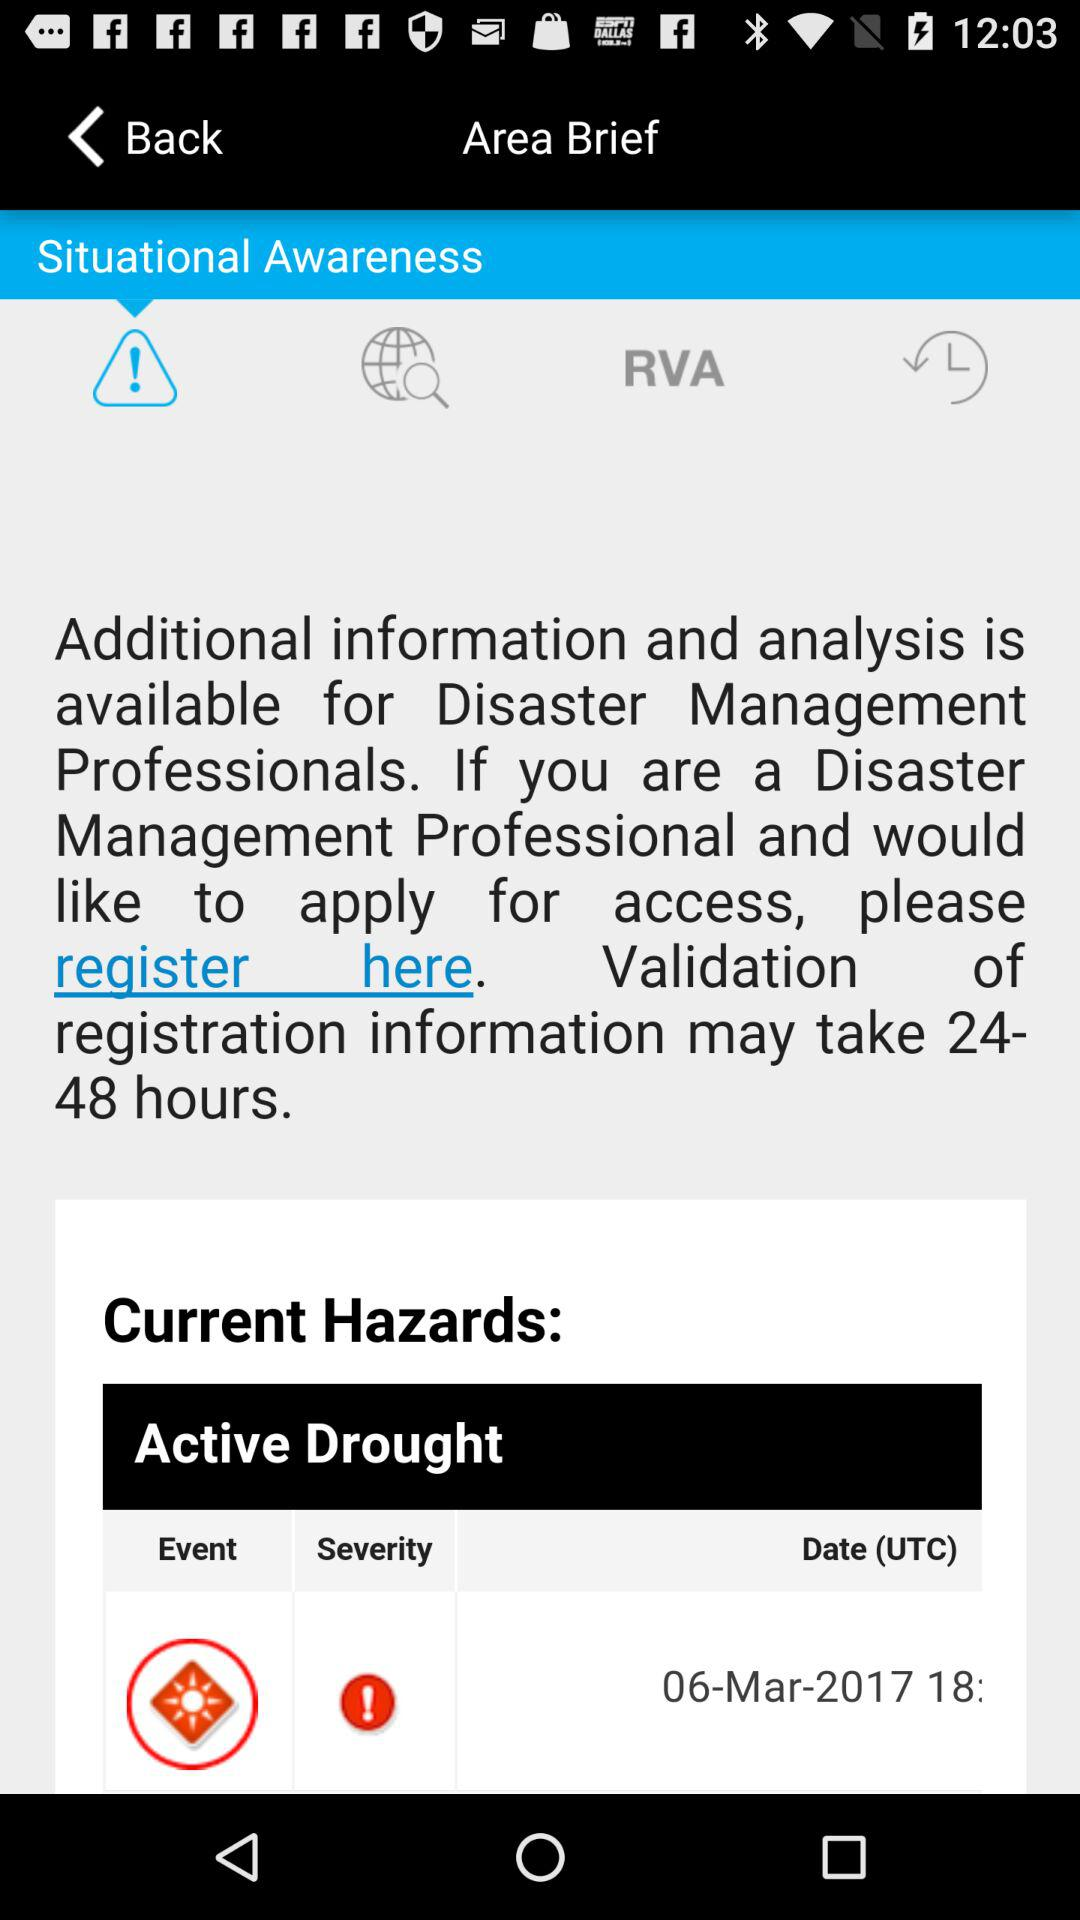Which tab is selected? The selected tab is "Situational Awareness". 